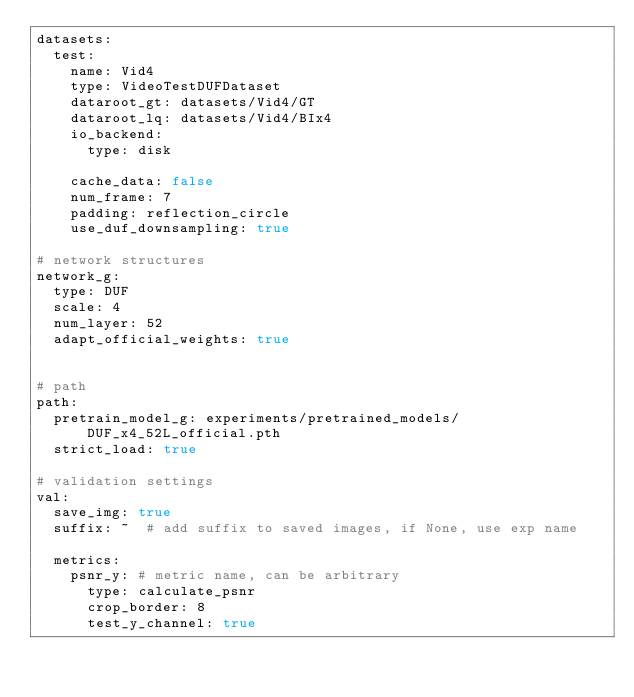<code> <loc_0><loc_0><loc_500><loc_500><_YAML_>datasets:
  test:
    name: Vid4
    type: VideoTestDUFDataset
    dataroot_gt: datasets/Vid4/GT
    dataroot_lq: datasets/Vid4/BIx4
    io_backend:
      type: disk

    cache_data: false
    num_frame: 7
    padding: reflection_circle
    use_duf_downsampling: true

# network structures
network_g:
  type: DUF
  scale: 4
  num_layer: 52
  adapt_official_weights: true


# path
path:
  pretrain_model_g: experiments/pretrained_models/DUF_x4_52L_official.pth
  strict_load: true

# validation settings
val:
  save_img: true
  suffix: ~  # add suffix to saved images, if None, use exp name

  metrics:
    psnr_y: # metric name, can be arbitrary
      type: calculate_psnr
      crop_border: 8
      test_y_channel: true
</code> 